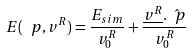Convert formula to latex. <formula><loc_0><loc_0><loc_500><loc_500>E ( \ p , v ^ { R } ) = \frac { E _ { s i m } } { v _ { 0 } ^ { R } } + \frac { \underline { v ^ { R } } . \hat { \ p } } { v _ { 0 } ^ { R } }</formula> 